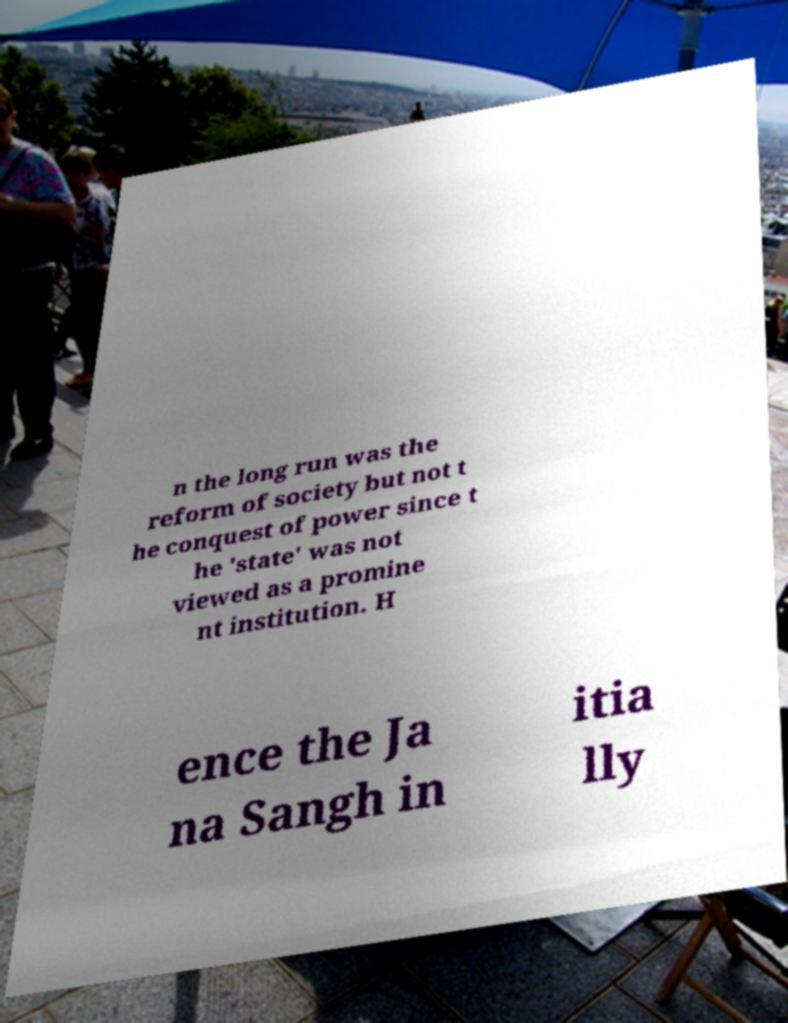There's text embedded in this image that I need extracted. Can you transcribe it verbatim? n the long run was the reform of society but not t he conquest of power since t he 'state' was not viewed as a promine nt institution. H ence the Ja na Sangh in itia lly 